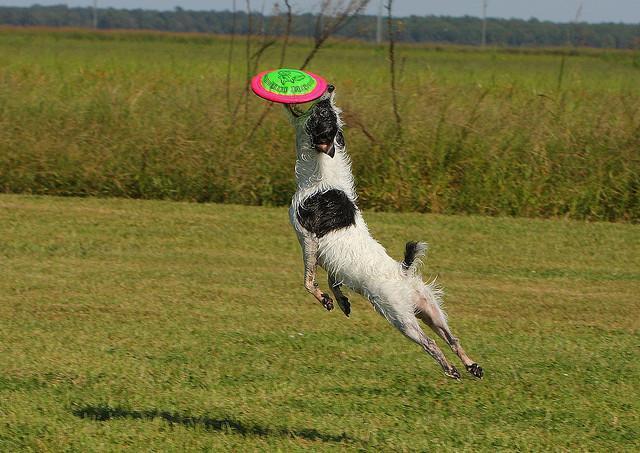How many dogs are in the picture?
Give a very brief answer. 1. How many birds are there in the picture?
Give a very brief answer. 0. 